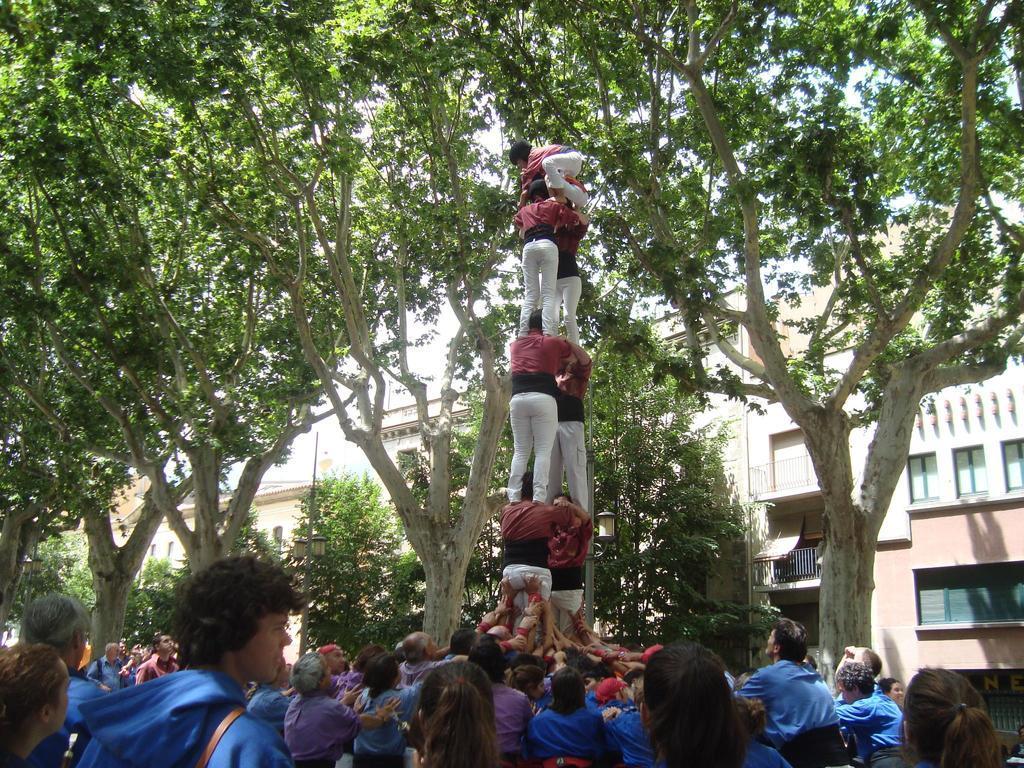In one or two sentences, can you explain what this image depicts? In this image there are group of persons in the front. In the background there are trees and there are buildings. 